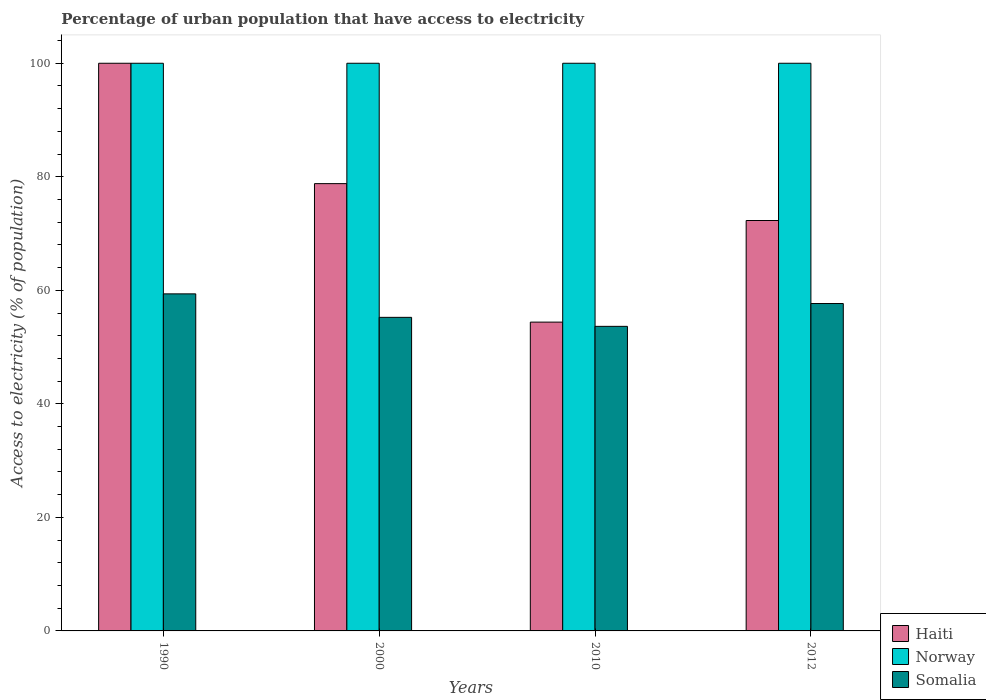How many different coloured bars are there?
Offer a terse response. 3. How many groups of bars are there?
Give a very brief answer. 4. Are the number of bars on each tick of the X-axis equal?
Offer a terse response. Yes. How many bars are there on the 1st tick from the left?
Give a very brief answer. 3. How many bars are there on the 4th tick from the right?
Keep it short and to the point. 3. What is the label of the 2nd group of bars from the left?
Offer a very short reply. 2000. What is the percentage of urban population that have access to electricity in Haiti in 2010?
Your answer should be compact. 54.4. Across all years, what is the maximum percentage of urban population that have access to electricity in Somalia?
Give a very brief answer. 59.38. Across all years, what is the minimum percentage of urban population that have access to electricity in Somalia?
Make the answer very short. 53.65. In which year was the percentage of urban population that have access to electricity in Haiti maximum?
Ensure brevity in your answer.  1990. In which year was the percentage of urban population that have access to electricity in Somalia minimum?
Offer a terse response. 2010. What is the total percentage of urban population that have access to electricity in Somalia in the graph?
Offer a terse response. 225.94. What is the difference between the percentage of urban population that have access to electricity in Norway in 2010 and that in 2012?
Make the answer very short. 0. What is the difference between the percentage of urban population that have access to electricity in Haiti in 2010 and the percentage of urban population that have access to electricity in Somalia in 1990?
Your response must be concise. -4.98. What is the average percentage of urban population that have access to electricity in Haiti per year?
Provide a succinct answer. 76.37. In the year 2012, what is the difference between the percentage of urban population that have access to electricity in Norway and percentage of urban population that have access to electricity in Haiti?
Your answer should be very brief. 27.7. In how many years, is the percentage of urban population that have access to electricity in Somalia greater than 44 %?
Offer a very short reply. 4. What is the ratio of the percentage of urban population that have access to electricity in Somalia in 1990 to that in 2010?
Provide a succinct answer. 1.11. Is the percentage of urban population that have access to electricity in Norway in 2000 less than that in 2010?
Keep it short and to the point. No. What is the difference between the highest and the second highest percentage of urban population that have access to electricity in Somalia?
Keep it short and to the point. 1.7. What is the difference between the highest and the lowest percentage of urban population that have access to electricity in Haiti?
Offer a terse response. 45.6. Is the sum of the percentage of urban population that have access to electricity in Haiti in 2000 and 2012 greater than the maximum percentage of urban population that have access to electricity in Norway across all years?
Your answer should be compact. Yes. What does the 1st bar from the right in 2012 represents?
Provide a short and direct response. Somalia. Is it the case that in every year, the sum of the percentage of urban population that have access to electricity in Somalia and percentage of urban population that have access to electricity in Haiti is greater than the percentage of urban population that have access to electricity in Norway?
Your response must be concise. Yes. How many years are there in the graph?
Your answer should be very brief. 4. What is the difference between two consecutive major ticks on the Y-axis?
Provide a short and direct response. 20. Are the values on the major ticks of Y-axis written in scientific E-notation?
Offer a terse response. No. Does the graph contain grids?
Offer a very short reply. No. How many legend labels are there?
Provide a short and direct response. 3. What is the title of the graph?
Ensure brevity in your answer.  Percentage of urban population that have access to electricity. What is the label or title of the Y-axis?
Ensure brevity in your answer.  Access to electricity (% of population). What is the Access to electricity (% of population) of Somalia in 1990?
Your answer should be very brief. 59.38. What is the Access to electricity (% of population) of Haiti in 2000?
Ensure brevity in your answer.  78.8. What is the Access to electricity (% of population) in Norway in 2000?
Provide a short and direct response. 100. What is the Access to electricity (% of population) of Somalia in 2000?
Make the answer very short. 55.24. What is the Access to electricity (% of population) of Haiti in 2010?
Provide a succinct answer. 54.4. What is the Access to electricity (% of population) in Somalia in 2010?
Keep it short and to the point. 53.65. What is the Access to electricity (% of population) in Haiti in 2012?
Keep it short and to the point. 72.3. What is the Access to electricity (% of population) of Norway in 2012?
Your answer should be compact. 100. What is the Access to electricity (% of population) in Somalia in 2012?
Provide a short and direct response. 57.67. Across all years, what is the maximum Access to electricity (% of population) in Somalia?
Your response must be concise. 59.38. Across all years, what is the minimum Access to electricity (% of population) of Haiti?
Make the answer very short. 54.4. Across all years, what is the minimum Access to electricity (% of population) of Norway?
Ensure brevity in your answer.  100. Across all years, what is the minimum Access to electricity (% of population) in Somalia?
Make the answer very short. 53.65. What is the total Access to electricity (% of population) in Haiti in the graph?
Provide a succinct answer. 305.5. What is the total Access to electricity (% of population) in Norway in the graph?
Ensure brevity in your answer.  400. What is the total Access to electricity (% of population) of Somalia in the graph?
Your response must be concise. 225.94. What is the difference between the Access to electricity (% of population) of Haiti in 1990 and that in 2000?
Make the answer very short. 21.2. What is the difference between the Access to electricity (% of population) of Somalia in 1990 and that in 2000?
Offer a very short reply. 4.14. What is the difference between the Access to electricity (% of population) of Haiti in 1990 and that in 2010?
Keep it short and to the point. 45.6. What is the difference between the Access to electricity (% of population) of Norway in 1990 and that in 2010?
Offer a terse response. 0. What is the difference between the Access to electricity (% of population) of Somalia in 1990 and that in 2010?
Offer a terse response. 5.72. What is the difference between the Access to electricity (% of population) of Haiti in 1990 and that in 2012?
Give a very brief answer. 27.7. What is the difference between the Access to electricity (% of population) in Norway in 1990 and that in 2012?
Give a very brief answer. 0. What is the difference between the Access to electricity (% of population) in Somalia in 1990 and that in 2012?
Provide a short and direct response. 1.7. What is the difference between the Access to electricity (% of population) in Haiti in 2000 and that in 2010?
Your answer should be compact. 24.39. What is the difference between the Access to electricity (% of population) of Norway in 2000 and that in 2010?
Your response must be concise. 0. What is the difference between the Access to electricity (% of population) of Somalia in 2000 and that in 2010?
Provide a succinct answer. 1.58. What is the difference between the Access to electricity (% of population) in Haiti in 2000 and that in 2012?
Your answer should be very brief. 6.5. What is the difference between the Access to electricity (% of population) of Norway in 2000 and that in 2012?
Give a very brief answer. 0. What is the difference between the Access to electricity (% of population) of Somalia in 2000 and that in 2012?
Provide a succinct answer. -2.44. What is the difference between the Access to electricity (% of population) of Haiti in 2010 and that in 2012?
Give a very brief answer. -17.9. What is the difference between the Access to electricity (% of population) in Norway in 2010 and that in 2012?
Offer a very short reply. 0. What is the difference between the Access to electricity (% of population) of Somalia in 2010 and that in 2012?
Offer a very short reply. -4.02. What is the difference between the Access to electricity (% of population) in Haiti in 1990 and the Access to electricity (% of population) in Norway in 2000?
Ensure brevity in your answer.  0. What is the difference between the Access to electricity (% of population) of Haiti in 1990 and the Access to electricity (% of population) of Somalia in 2000?
Make the answer very short. 44.76. What is the difference between the Access to electricity (% of population) of Norway in 1990 and the Access to electricity (% of population) of Somalia in 2000?
Your answer should be very brief. 44.76. What is the difference between the Access to electricity (% of population) of Haiti in 1990 and the Access to electricity (% of population) of Norway in 2010?
Provide a succinct answer. 0. What is the difference between the Access to electricity (% of population) in Haiti in 1990 and the Access to electricity (% of population) in Somalia in 2010?
Offer a very short reply. 46.35. What is the difference between the Access to electricity (% of population) of Norway in 1990 and the Access to electricity (% of population) of Somalia in 2010?
Offer a very short reply. 46.35. What is the difference between the Access to electricity (% of population) in Haiti in 1990 and the Access to electricity (% of population) in Somalia in 2012?
Offer a terse response. 42.33. What is the difference between the Access to electricity (% of population) of Norway in 1990 and the Access to electricity (% of population) of Somalia in 2012?
Keep it short and to the point. 42.33. What is the difference between the Access to electricity (% of population) in Haiti in 2000 and the Access to electricity (% of population) in Norway in 2010?
Provide a succinct answer. -21.2. What is the difference between the Access to electricity (% of population) in Haiti in 2000 and the Access to electricity (% of population) in Somalia in 2010?
Keep it short and to the point. 25.14. What is the difference between the Access to electricity (% of population) of Norway in 2000 and the Access to electricity (% of population) of Somalia in 2010?
Your response must be concise. 46.35. What is the difference between the Access to electricity (% of population) in Haiti in 2000 and the Access to electricity (% of population) in Norway in 2012?
Give a very brief answer. -21.2. What is the difference between the Access to electricity (% of population) of Haiti in 2000 and the Access to electricity (% of population) of Somalia in 2012?
Provide a succinct answer. 21.12. What is the difference between the Access to electricity (% of population) of Norway in 2000 and the Access to electricity (% of population) of Somalia in 2012?
Provide a succinct answer. 42.33. What is the difference between the Access to electricity (% of population) of Haiti in 2010 and the Access to electricity (% of population) of Norway in 2012?
Ensure brevity in your answer.  -45.6. What is the difference between the Access to electricity (% of population) of Haiti in 2010 and the Access to electricity (% of population) of Somalia in 2012?
Keep it short and to the point. -3.27. What is the difference between the Access to electricity (% of population) in Norway in 2010 and the Access to electricity (% of population) in Somalia in 2012?
Your answer should be compact. 42.33. What is the average Access to electricity (% of population) of Haiti per year?
Keep it short and to the point. 76.37. What is the average Access to electricity (% of population) of Somalia per year?
Give a very brief answer. 56.49. In the year 1990, what is the difference between the Access to electricity (% of population) of Haiti and Access to electricity (% of population) of Norway?
Your answer should be very brief. 0. In the year 1990, what is the difference between the Access to electricity (% of population) in Haiti and Access to electricity (% of population) in Somalia?
Offer a very short reply. 40.62. In the year 1990, what is the difference between the Access to electricity (% of population) of Norway and Access to electricity (% of population) of Somalia?
Make the answer very short. 40.62. In the year 2000, what is the difference between the Access to electricity (% of population) in Haiti and Access to electricity (% of population) in Norway?
Your answer should be compact. -21.2. In the year 2000, what is the difference between the Access to electricity (% of population) of Haiti and Access to electricity (% of population) of Somalia?
Your answer should be very brief. 23.56. In the year 2000, what is the difference between the Access to electricity (% of population) in Norway and Access to electricity (% of population) in Somalia?
Your response must be concise. 44.76. In the year 2010, what is the difference between the Access to electricity (% of population) in Haiti and Access to electricity (% of population) in Norway?
Offer a terse response. -45.6. In the year 2010, what is the difference between the Access to electricity (% of population) in Haiti and Access to electricity (% of population) in Somalia?
Make the answer very short. 0.75. In the year 2010, what is the difference between the Access to electricity (% of population) in Norway and Access to electricity (% of population) in Somalia?
Offer a very short reply. 46.35. In the year 2012, what is the difference between the Access to electricity (% of population) in Haiti and Access to electricity (% of population) in Norway?
Provide a succinct answer. -27.7. In the year 2012, what is the difference between the Access to electricity (% of population) of Haiti and Access to electricity (% of population) of Somalia?
Make the answer very short. 14.63. In the year 2012, what is the difference between the Access to electricity (% of population) in Norway and Access to electricity (% of population) in Somalia?
Your answer should be very brief. 42.33. What is the ratio of the Access to electricity (% of population) of Haiti in 1990 to that in 2000?
Provide a short and direct response. 1.27. What is the ratio of the Access to electricity (% of population) in Norway in 1990 to that in 2000?
Give a very brief answer. 1. What is the ratio of the Access to electricity (% of population) of Somalia in 1990 to that in 2000?
Your answer should be compact. 1.07. What is the ratio of the Access to electricity (% of population) in Haiti in 1990 to that in 2010?
Your response must be concise. 1.84. What is the ratio of the Access to electricity (% of population) in Norway in 1990 to that in 2010?
Offer a very short reply. 1. What is the ratio of the Access to electricity (% of population) of Somalia in 1990 to that in 2010?
Provide a short and direct response. 1.11. What is the ratio of the Access to electricity (% of population) of Haiti in 1990 to that in 2012?
Keep it short and to the point. 1.38. What is the ratio of the Access to electricity (% of population) of Somalia in 1990 to that in 2012?
Provide a succinct answer. 1.03. What is the ratio of the Access to electricity (% of population) in Haiti in 2000 to that in 2010?
Give a very brief answer. 1.45. What is the ratio of the Access to electricity (% of population) of Somalia in 2000 to that in 2010?
Your answer should be very brief. 1.03. What is the ratio of the Access to electricity (% of population) in Haiti in 2000 to that in 2012?
Your response must be concise. 1.09. What is the ratio of the Access to electricity (% of population) in Somalia in 2000 to that in 2012?
Your answer should be compact. 0.96. What is the ratio of the Access to electricity (% of population) of Haiti in 2010 to that in 2012?
Ensure brevity in your answer.  0.75. What is the ratio of the Access to electricity (% of population) in Somalia in 2010 to that in 2012?
Your response must be concise. 0.93. What is the difference between the highest and the second highest Access to electricity (% of population) in Haiti?
Your response must be concise. 21.2. What is the difference between the highest and the second highest Access to electricity (% of population) in Somalia?
Provide a short and direct response. 1.7. What is the difference between the highest and the lowest Access to electricity (% of population) in Haiti?
Provide a short and direct response. 45.6. What is the difference between the highest and the lowest Access to electricity (% of population) in Somalia?
Make the answer very short. 5.72. 